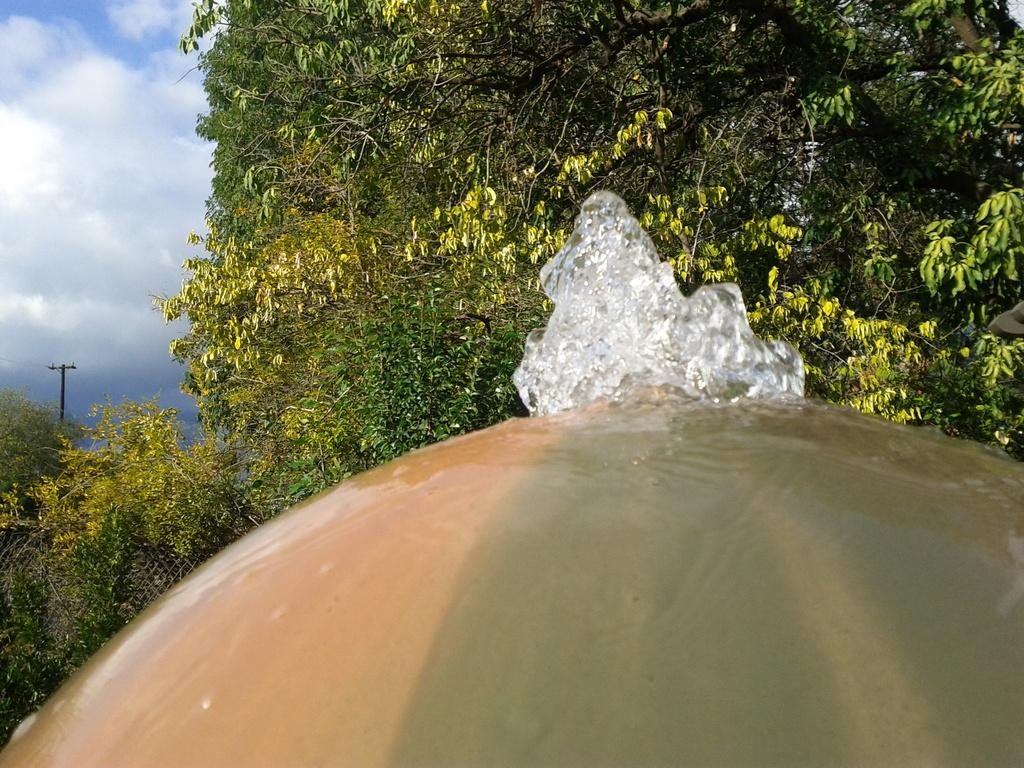What is located at the bottom of the image? There is a fountain at the bottom of the image. What type of vegetation is on the right side of the image? There are trees on the right side of the image. What is visible on the left side of the image? The sky is visible on the left side of the image. Can you see any leather items in the image? There is no mention of leather items in the image, so we cannot determine if any are present. Are there any boats or ships visible in the image? The provided facts do not mention a harbor or any water-related elements, so we cannot determine if there are any boats or ships visible in the image. 